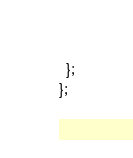Convert code to text. <code><loc_0><loc_0><loc_500><loc_500><_JavaScript_>  };
};
</code> 